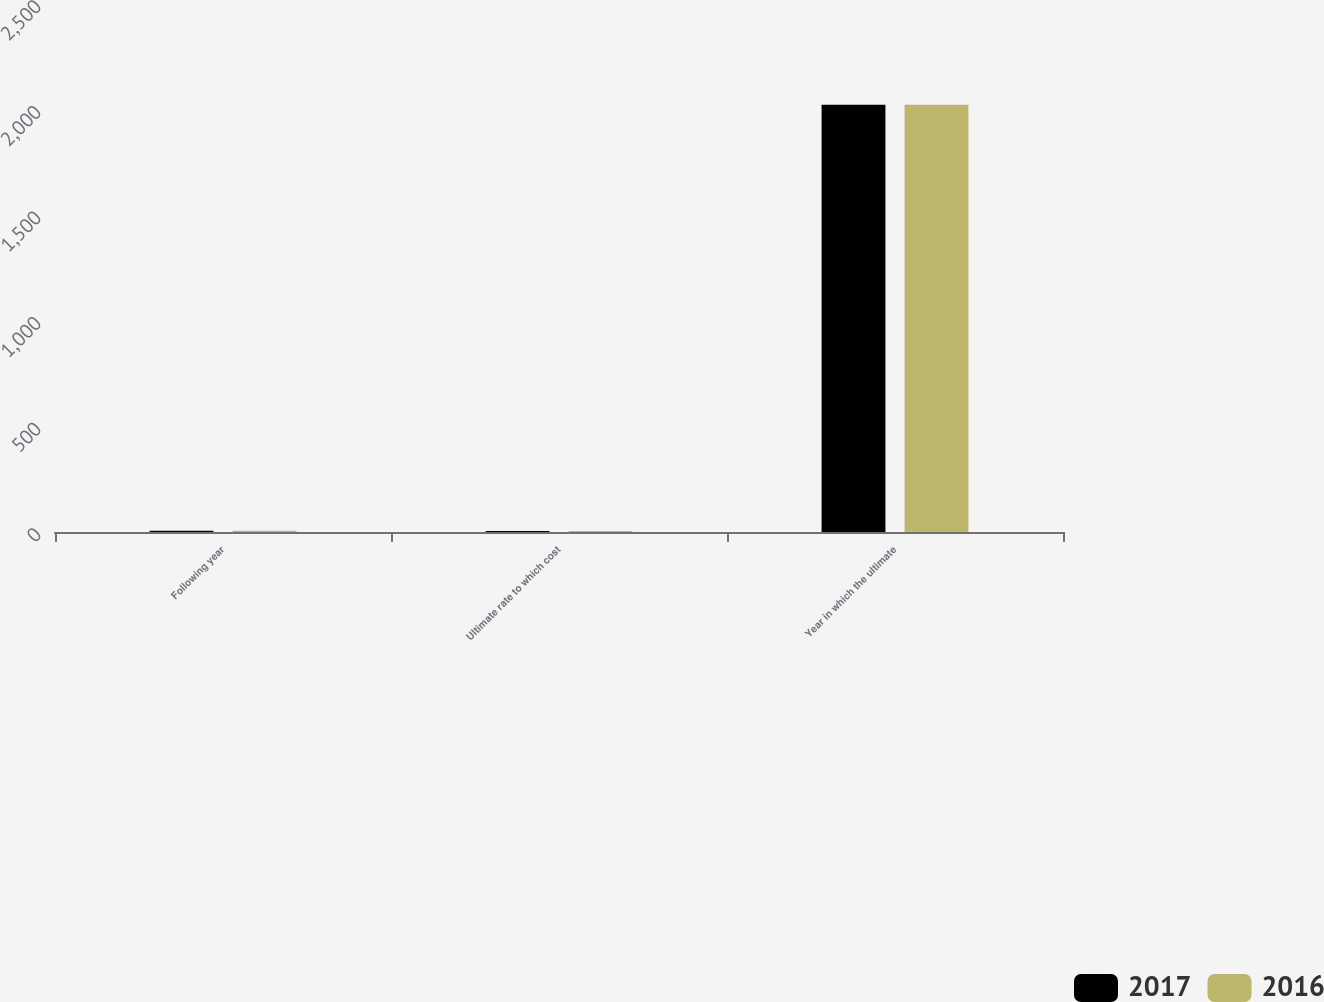Convert chart. <chart><loc_0><loc_0><loc_500><loc_500><stacked_bar_chart><ecel><fcel>Following year<fcel>Ultimate rate to which cost<fcel>Year in which the ultimate<nl><fcel>2017<fcel>6.5<fcel>5<fcel>2023<nl><fcel>2016<fcel>6.5<fcel>5<fcel>2023<nl></chart> 